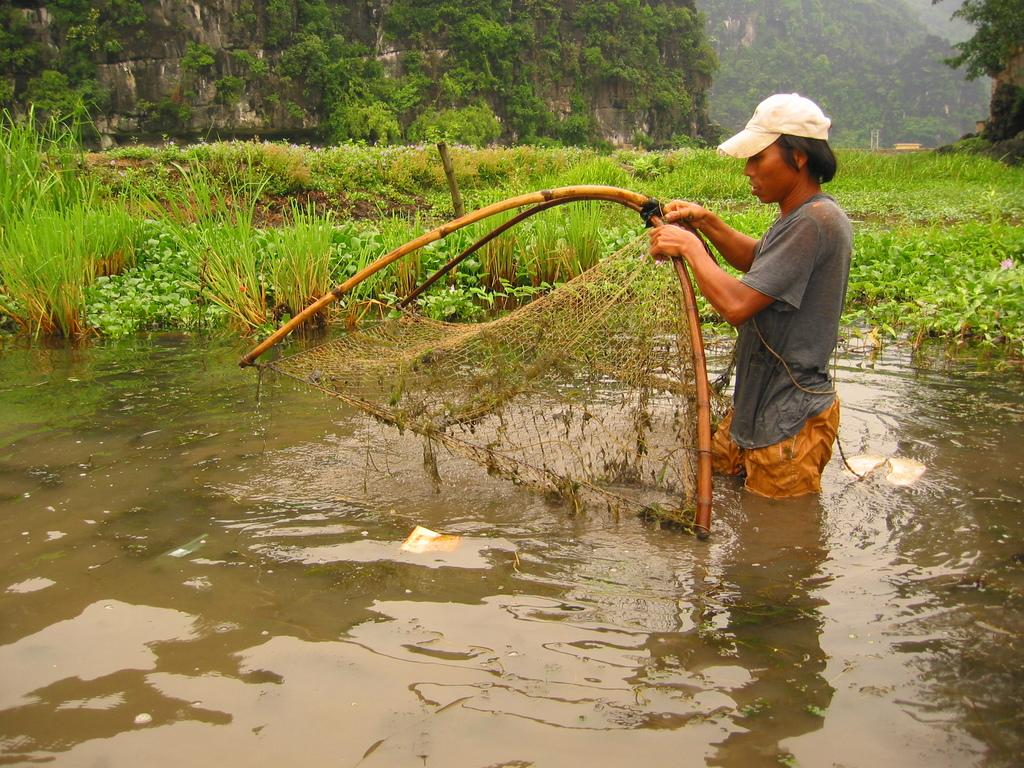What is the person in the image doing? The person is standing in water. What is the person holding in the image? The person is holding wooden objects. What is attached to the wooden objects? Mesh is tied to the wooden objects. What can be seen in the background of the image? There are plants and grass in the background of the image. Where are the plants located? The plants are on mountains. What type of feast is being held in the image? There is no feast present in the image; it features a person standing in water with wooden objects and mesh. 